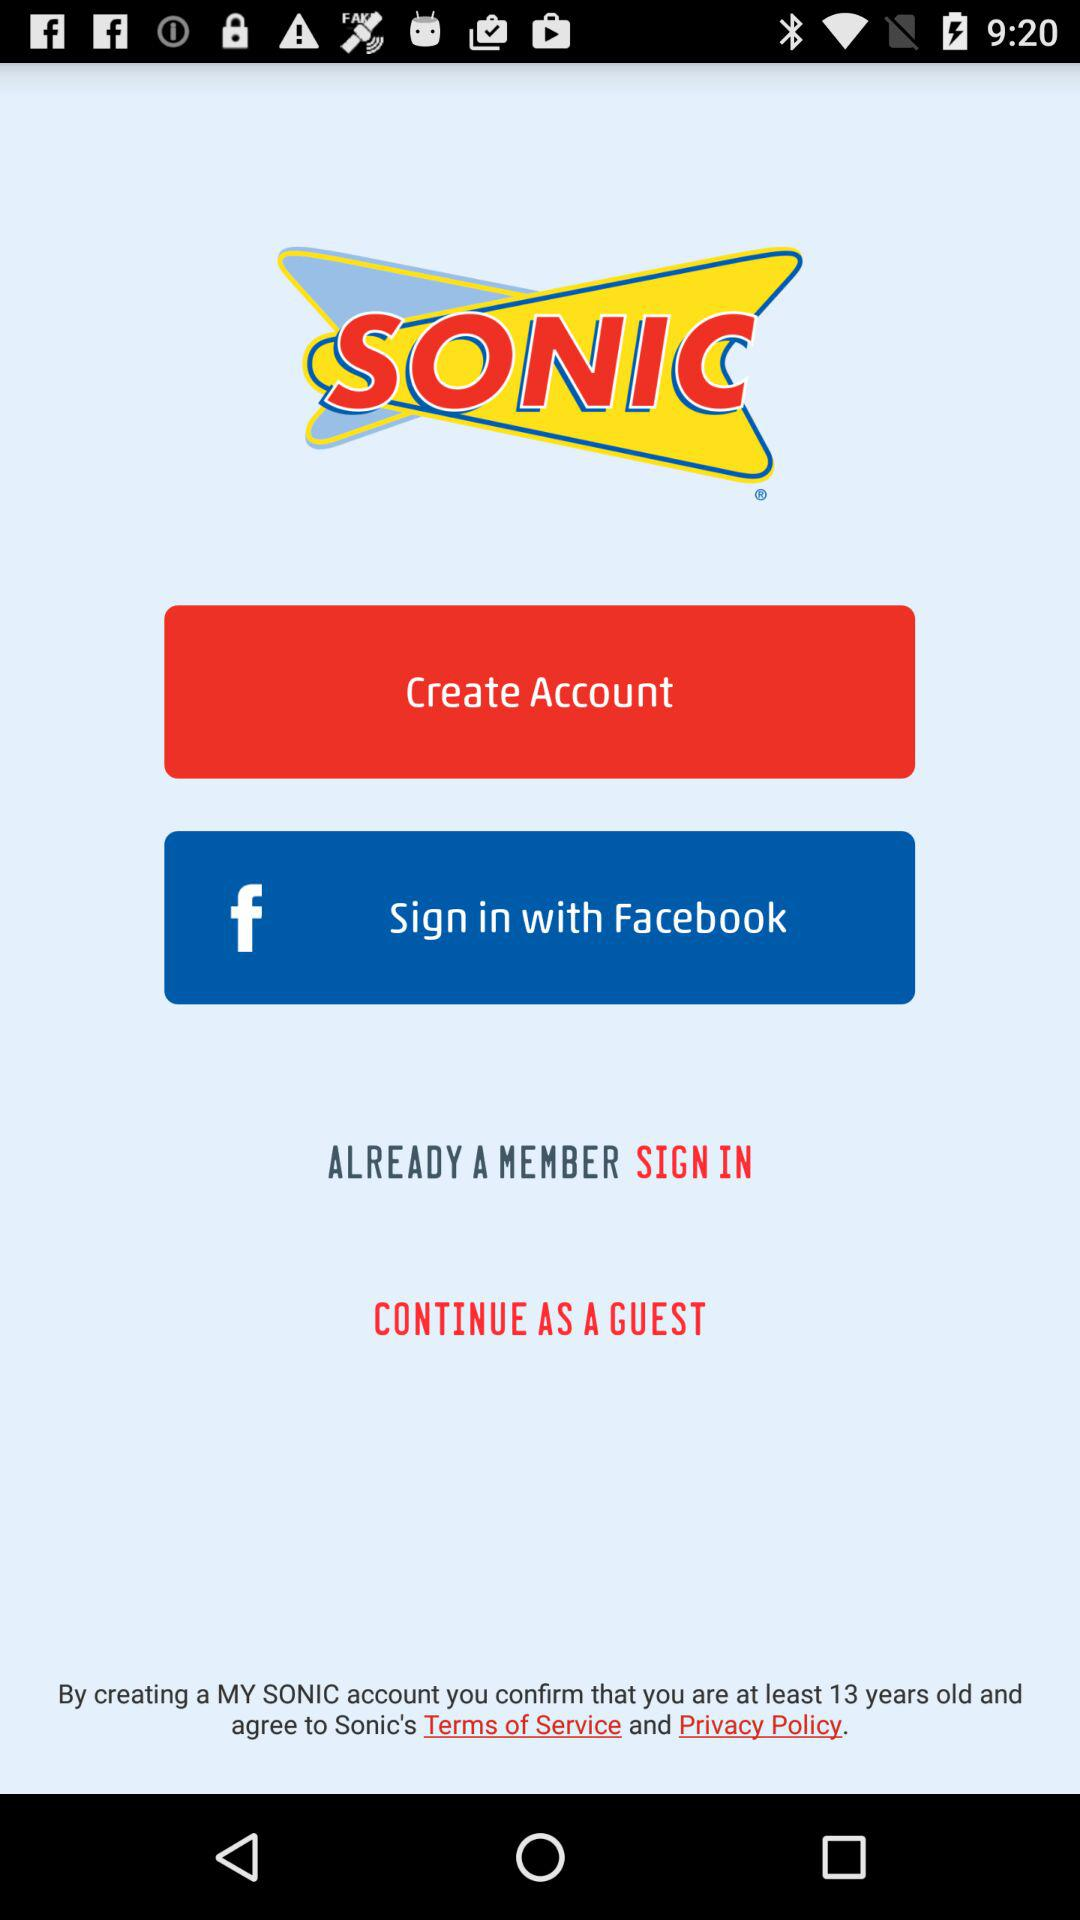What app can we use to sign in? You can sign in with "Facebook". 